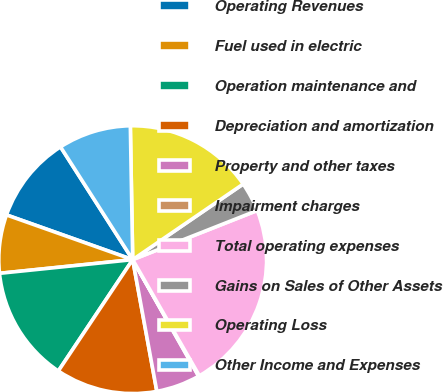Convert chart. <chart><loc_0><loc_0><loc_500><loc_500><pie_chart><fcel>Operating Revenues<fcel>Fuel used in electric<fcel>Operation maintenance and<fcel>Depreciation and amortization<fcel>Property and other taxes<fcel>Impairment charges<fcel>Total operating expenses<fcel>Gains on Sales of Other Assets<fcel>Operating Loss<fcel>Other Income and Expenses<nl><fcel>10.52%<fcel>7.05%<fcel>14.0%<fcel>12.26%<fcel>5.31%<fcel>0.1%<fcel>22.69%<fcel>3.57%<fcel>15.73%<fcel>8.78%<nl></chart> 